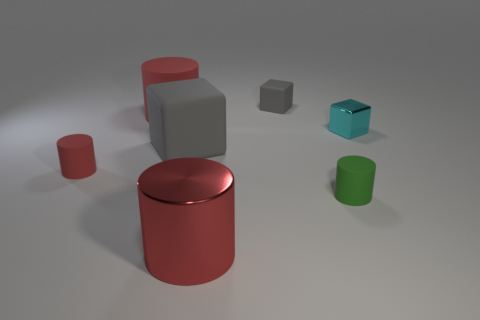How many red cylinders must be subtracted to get 1 red cylinders? 2 Add 1 big red things. How many objects exist? 8 Subtract all tiny red cylinders. How many cylinders are left? 3 Subtract all cyan cubes. How many red cylinders are left? 3 Subtract all gray cubes. How many cubes are left? 1 Subtract 3 cylinders. How many cylinders are left? 1 Subtract all blocks. How many objects are left? 4 Add 1 tiny red cubes. How many tiny red cubes exist? 1 Subtract 0 green balls. How many objects are left? 7 Subtract all yellow cylinders. Subtract all green balls. How many cylinders are left? 4 